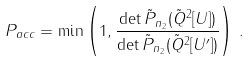<formula> <loc_0><loc_0><loc_500><loc_500>P _ { a c c } = \min \left ( 1 , \frac { \det \tilde { P } _ { n _ { 2 } } ( \tilde { Q } ^ { 2 } [ U ] ) } { \det \tilde { P } _ { n _ { 2 } } ( \tilde { Q } ^ { 2 } [ U ^ { \prime } ] ) } \right ) \, .</formula> 